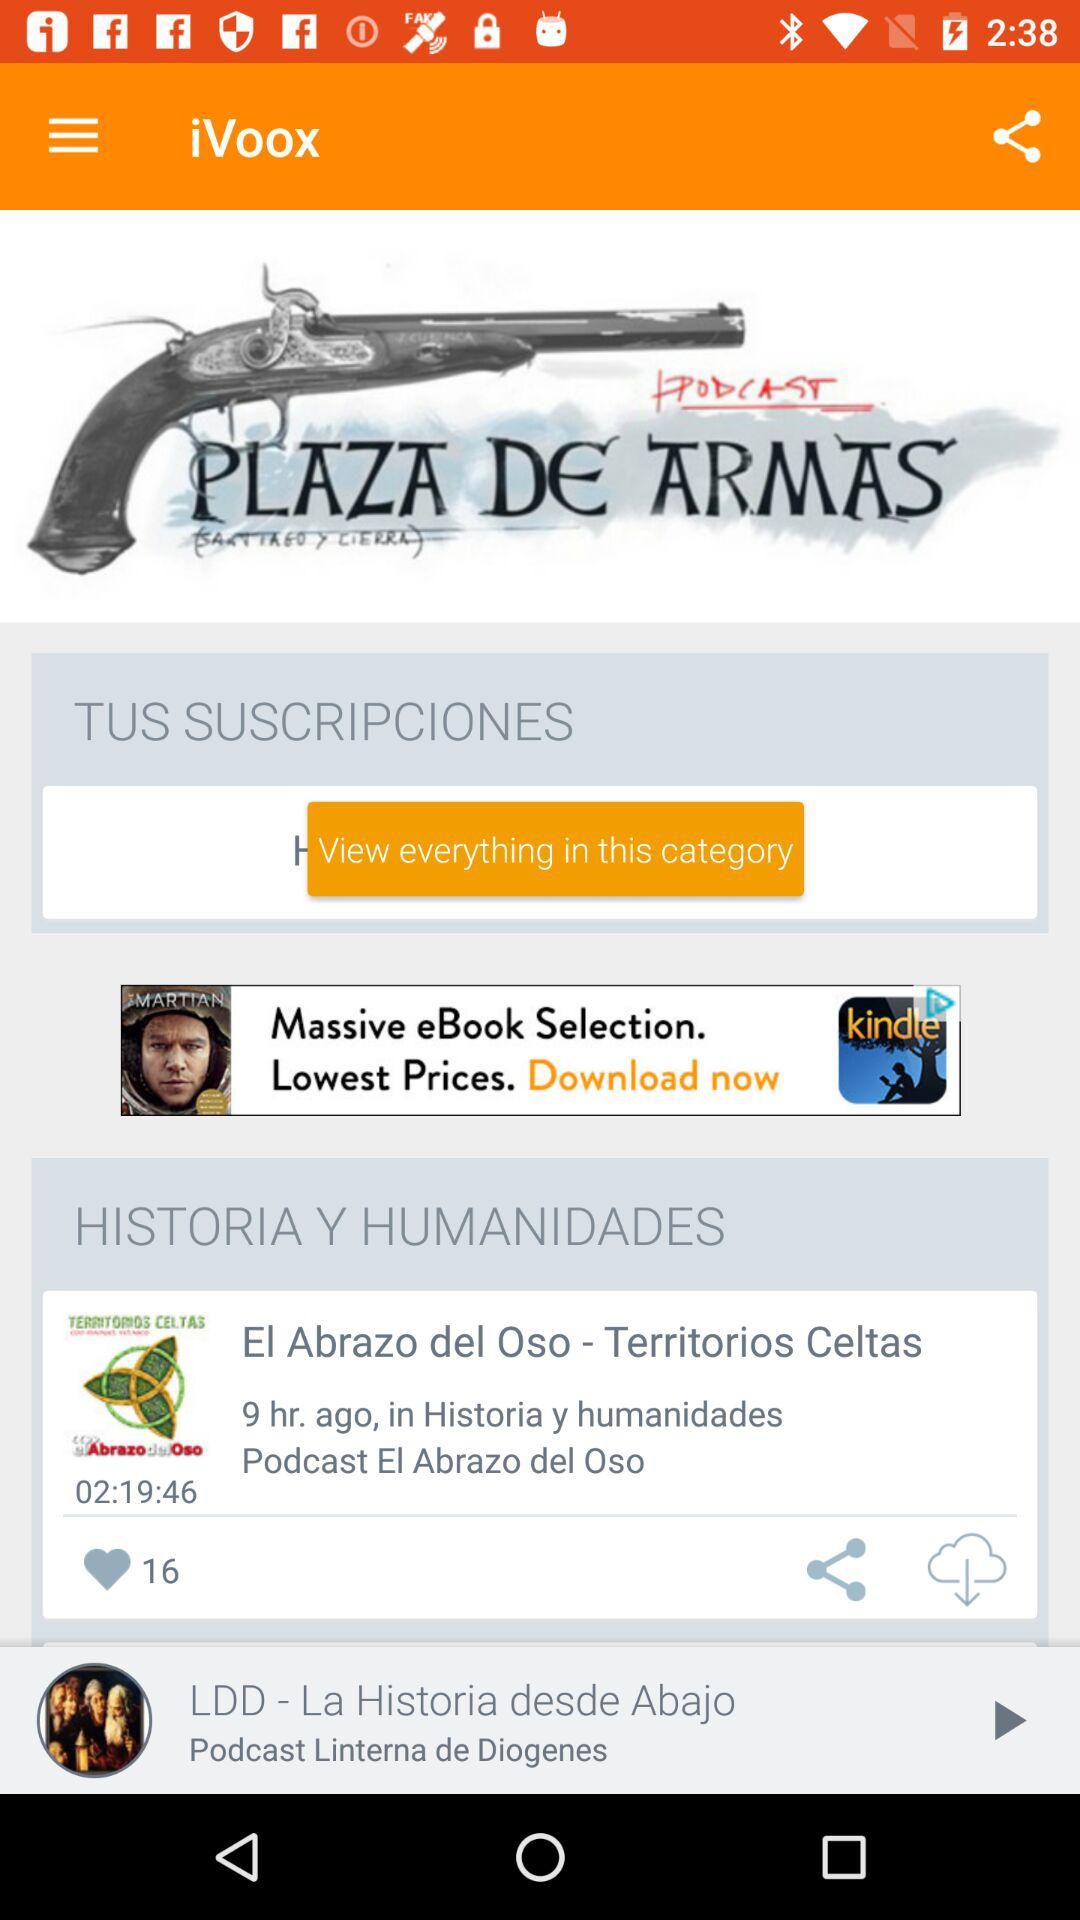How many minutes long is the podcast 'El Abrazo del Oso'?
Answer the question using a single word or phrase. 139 